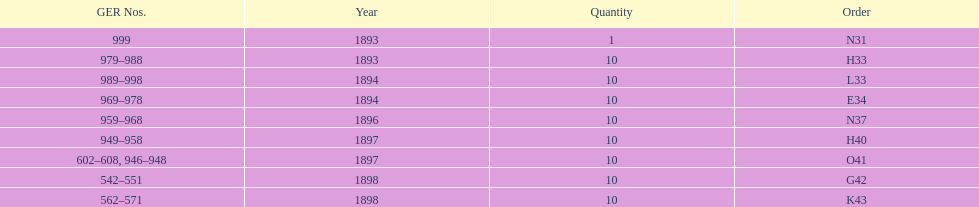What is the last year listed? 1898. 